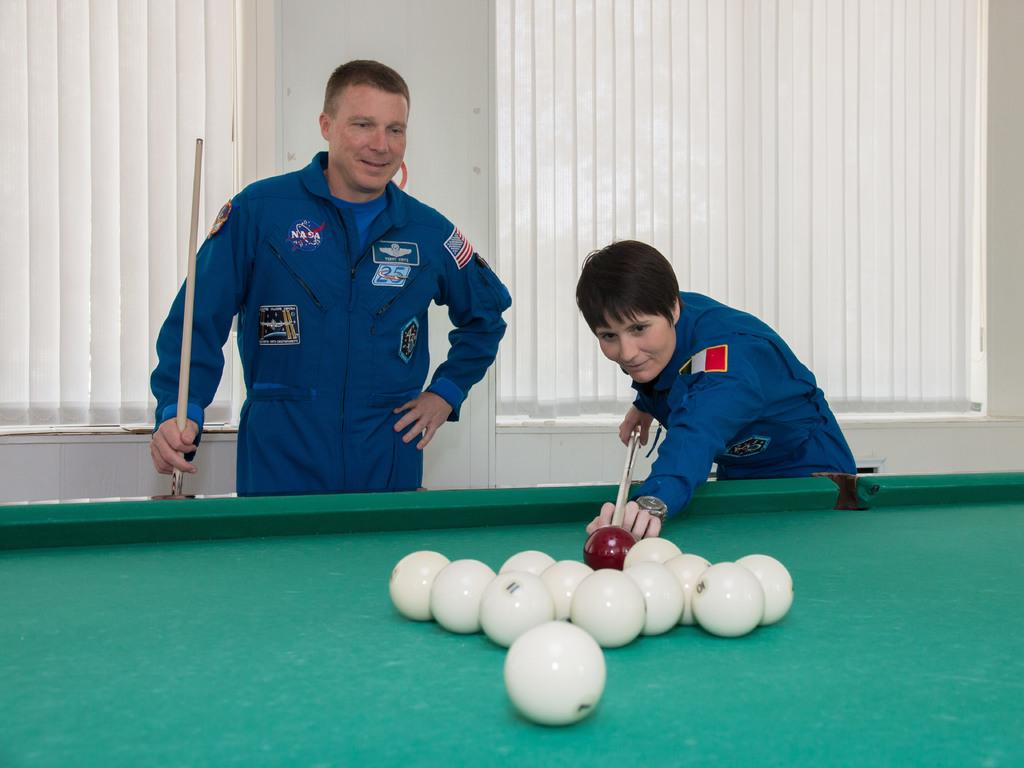Who is present in the image? There is a man and a woman in the image. What are they wearing? Both the man and woman are wearing uniforms. What activity are they engaged in? They are playing snookers. On what surface is the game being played? The game is being played on a snooker board. What type of insurance policy do the dolls in the image have? There are no dolls present in the image, so there is no information about any insurance policies. 